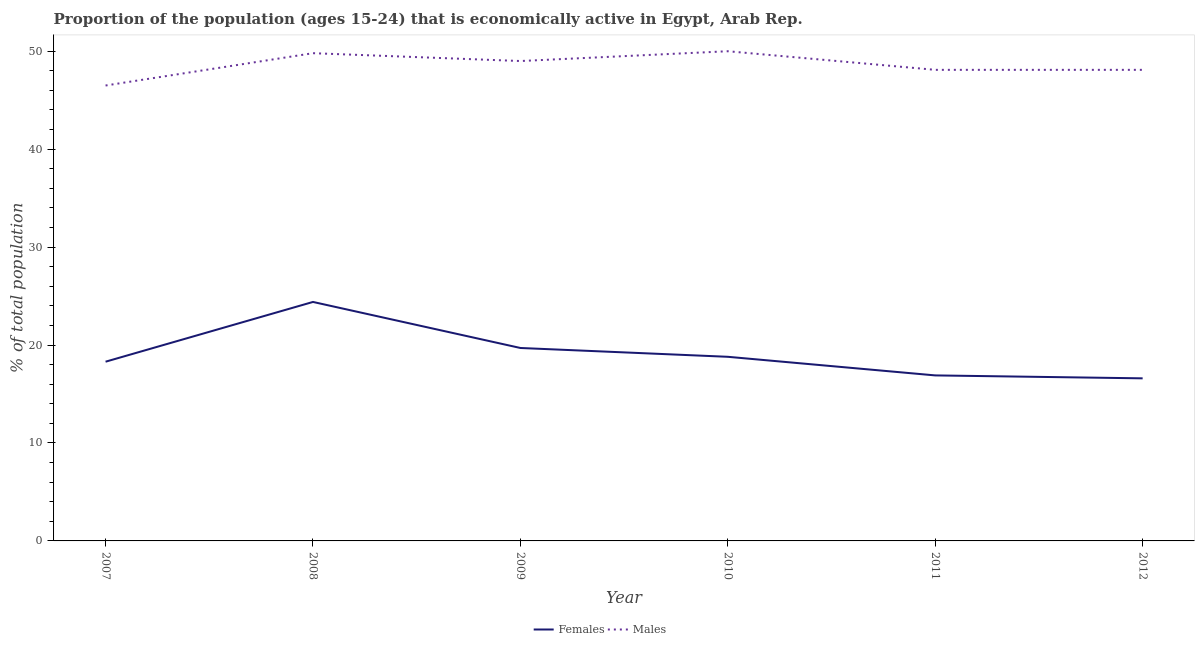Does the line corresponding to percentage of economically active male population intersect with the line corresponding to percentage of economically active female population?
Keep it short and to the point. No. What is the percentage of economically active female population in 2012?
Keep it short and to the point. 16.6. Across all years, what is the maximum percentage of economically active female population?
Ensure brevity in your answer.  24.4. Across all years, what is the minimum percentage of economically active female population?
Provide a short and direct response. 16.6. What is the total percentage of economically active male population in the graph?
Provide a succinct answer. 291.5. What is the difference between the percentage of economically active female population in 2008 and that in 2012?
Provide a short and direct response. 7.8. What is the difference between the percentage of economically active female population in 2012 and the percentage of economically active male population in 2010?
Provide a short and direct response. -33.4. What is the average percentage of economically active female population per year?
Offer a terse response. 19.12. In the year 2011, what is the difference between the percentage of economically active female population and percentage of economically active male population?
Your answer should be compact. -31.2. In how many years, is the percentage of economically active female population greater than 24 %?
Provide a succinct answer. 1. What is the ratio of the percentage of economically active female population in 2008 to that in 2009?
Ensure brevity in your answer.  1.24. Is the difference between the percentage of economically active male population in 2007 and 2009 greater than the difference between the percentage of economically active female population in 2007 and 2009?
Offer a very short reply. No. What is the difference between the highest and the second highest percentage of economically active female population?
Offer a very short reply. 4.7. In how many years, is the percentage of economically active male population greater than the average percentage of economically active male population taken over all years?
Offer a terse response. 3. Does the percentage of economically active female population monotonically increase over the years?
Your answer should be compact. No. Is the percentage of economically active female population strictly less than the percentage of economically active male population over the years?
Offer a very short reply. Yes. What is the difference between two consecutive major ticks on the Y-axis?
Make the answer very short. 10. Does the graph contain any zero values?
Provide a succinct answer. No. Does the graph contain grids?
Ensure brevity in your answer.  No. How many legend labels are there?
Your answer should be compact. 2. How are the legend labels stacked?
Keep it short and to the point. Horizontal. What is the title of the graph?
Provide a short and direct response. Proportion of the population (ages 15-24) that is economically active in Egypt, Arab Rep. What is the label or title of the X-axis?
Give a very brief answer. Year. What is the label or title of the Y-axis?
Provide a succinct answer. % of total population. What is the % of total population in Females in 2007?
Your answer should be compact. 18.3. What is the % of total population in Males in 2007?
Give a very brief answer. 46.5. What is the % of total population in Females in 2008?
Provide a succinct answer. 24.4. What is the % of total population of Males in 2008?
Offer a very short reply. 49.8. What is the % of total population in Females in 2009?
Offer a terse response. 19.7. What is the % of total population of Females in 2010?
Offer a very short reply. 18.8. What is the % of total population of Females in 2011?
Offer a very short reply. 16.9. What is the % of total population in Males in 2011?
Give a very brief answer. 48.1. What is the % of total population of Females in 2012?
Offer a terse response. 16.6. What is the % of total population in Males in 2012?
Offer a terse response. 48.1. Across all years, what is the maximum % of total population in Females?
Ensure brevity in your answer.  24.4. Across all years, what is the maximum % of total population of Males?
Provide a succinct answer. 50. Across all years, what is the minimum % of total population in Females?
Provide a succinct answer. 16.6. Across all years, what is the minimum % of total population of Males?
Give a very brief answer. 46.5. What is the total % of total population of Females in the graph?
Ensure brevity in your answer.  114.7. What is the total % of total population in Males in the graph?
Give a very brief answer. 291.5. What is the difference between the % of total population of Males in 2007 and that in 2008?
Make the answer very short. -3.3. What is the difference between the % of total population of Females in 2007 and that in 2009?
Your response must be concise. -1.4. What is the difference between the % of total population in Females in 2007 and that in 2011?
Your answer should be very brief. 1.4. What is the difference between the % of total population in Males in 2007 and that in 2011?
Provide a succinct answer. -1.6. What is the difference between the % of total population in Males in 2007 and that in 2012?
Provide a succinct answer. -1.6. What is the difference between the % of total population in Females in 2008 and that in 2009?
Give a very brief answer. 4.7. What is the difference between the % of total population of Males in 2008 and that in 2010?
Provide a succinct answer. -0.2. What is the difference between the % of total population of Males in 2008 and that in 2011?
Your answer should be very brief. 1.7. What is the difference between the % of total population in Males in 2009 and that in 2010?
Provide a succinct answer. -1. What is the difference between the % of total population in Females in 2009 and that in 2011?
Keep it short and to the point. 2.8. What is the difference between the % of total population of Females in 2010 and that in 2012?
Your answer should be very brief. 2.2. What is the difference between the % of total population of Males in 2011 and that in 2012?
Provide a succinct answer. 0. What is the difference between the % of total population of Females in 2007 and the % of total population of Males in 2008?
Your answer should be compact. -31.5. What is the difference between the % of total population of Females in 2007 and the % of total population of Males in 2009?
Provide a short and direct response. -30.7. What is the difference between the % of total population in Females in 2007 and the % of total population in Males in 2010?
Offer a terse response. -31.7. What is the difference between the % of total population in Females in 2007 and the % of total population in Males in 2011?
Keep it short and to the point. -29.8. What is the difference between the % of total population in Females in 2007 and the % of total population in Males in 2012?
Make the answer very short. -29.8. What is the difference between the % of total population of Females in 2008 and the % of total population of Males in 2009?
Your response must be concise. -24.6. What is the difference between the % of total population in Females in 2008 and the % of total population in Males in 2010?
Ensure brevity in your answer.  -25.6. What is the difference between the % of total population in Females in 2008 and the % of total population in Males in 2011?
Offer a terse response. -23.7. What is the difference between the % of total population in Females in 2008 and the % of total population in Males in 2012?
Make the answer very short. -23.7. What is the difference between the % of total population in Females in 2009 and the % of total population in Males in 2010?
Make the answer very short. -30.3. What is the difference between the % of total population of Females in 2009 and the % of total population of Males in 2011?
Make the answer very short. -28.4. What is the difference between the % of total population of Females in 2009 and the % of total population of Males in 2012?
Offer a very short reply. -28.4. What is the difference between the % of total population of Females in 2010 and the % of total population of Males in 2011?
Provide a succinct answer. -29.3. What is the difference between the % of total population in Females in 2010 and the % of total population in Males in 2012?
Your answer should be compact. -29.3. What is the difference between the % of total population of Females in 2011 and the % of total population of Males in 2012?
Ensure brevity in your answer.  -31.2. What is the average % of total population of Females per year?
Provide a succinct answer. 19.12. What is the average % of total population in Males per year?
Your answer should be very brief. 48.58. In the year 2007, what is the difference between the % of total population in Females and % of total population in Males?
Give a very brief answer. -28.2. In the year 2008, what is the difference between the % of total population in Females and % of total population in Males?
Give a very brief answer. -25.4. In the year 2009, what is the difference between the % of total population of Females and % of total population of Males?
Offer a terse response. -29.3. In the year 2010, what is the difference between the % of total population of Females and % of total population of Males?
Offer a very short reply. -31.2. In the year 2011, what is the difference between the % of total population of Females and % of total population of Males?
Your answer should be very brief. -31.2. In the year 2012, what is the difference between the % of total population in Females and % of total population in Males?
Offer a very short reply. -31.5. What is the ratio of the % of total population of Females in 2007 to that in 2008?
Provide a short and direct response. 0.75. What is the ratio of the % of total population of Males in 2007 to that in 2008?
Your answer should be very brief. 0.93. What is the ratio of the % of total population of Females in 2007 to that in 2009?
Your answer should be very brief. 0.93. What is the ratio of the % of total population in Males in 2007 to that in 2009?
Provide a short and direct response. 0.95. What is the ratio of the % of total population of Females in 2007 to that in 2010?
Your response must be concise. 0.97. What is the ratio of the % of total population of Males in 2007 to that in 2010?
Your response must be concise. 0.93. What is the ratio of the % of total population of Females in 2007 to that in 2011?
Ensure brevity in your answer.  1.08. What is the ratio of the % of total population of Males in 2007 to that in 2011?
Your answer should be very brief. 0.97. What is the ratio of the % of total population in Females in 2007 to that in 2012?
Give a very brief answer. 1.1. What is the ratio of the % of total population in Males in 2007 to that in 2012?
Provide a short and direct response. 0.97. What is the ratio of the % of total population of Females in 2008 to that in 2009?
Give a very brief answer. 1.24. What is the ratio of the % of total population of Males in 2008 to that in 2009?
Keep it short and to the point. 1.02. What is the ratio of the % of total population of Females in 2008 to that in 2010?
Your response must be concise. 1.3. What is the ratio of the % of total population of Females in 2008 to that in 2011?
Your response must be concise. 1.44. What is the ratio of the % of total population in Males in 2008 to that in 2011?
Offer a terse response. 1.04. What is the ratio of the % of total population in Females in 2008 to that in 2012?
Provide a short and direct response. 1.47. What is the ratio of the % of total population of Males in 2008 to that in 2012?
Your response must be concise. 1.04. What is the ratio of the % of total population of Females in 2009 to that in 2010?
Make the answer very short. 1.05. What is the ratio of the % of total population in Females in 2009 to that in 2011?
Offer a terse response. 1.17. What is the ratio of the % of total population in Males in 2009 to that in 2011?
Offer a terse response. 1.02. What is the ratio of the % of total population of Females in 2009 to that in 2012?
Keep it short and to the point. 1.19. What is the ratio of the % of total population of Males in 2009 to that in 2012?
Ensure brevity in your answer.  1.02. What is the ratio of the % of total population of Females in 2010 to that in 2011?
Make the answer very short. 1.11. What is the ratio of the % of total population of Males in 2010 to that in 2011?
Ensure brevity in your answer.  1.04. What is the ratio of the % of total population of Females in 2010 to that in 2012?
Your answer should be compact. 1.13. What is the ratio of the % of total population of Males in 2010 to that in 2012?
Your answer should be very brief. 1.04. What is the ratio of the % of total population of Females in 2011 to that in 2012?
Your answer should be very brief. 1.02. What is the difference between the highest and the second highest % of total population in Females?
Your answer should be compact. 4.7. What is the difference between the highest and the second highest % of total population of Males?
Provide a succinct answer. 0.2. 